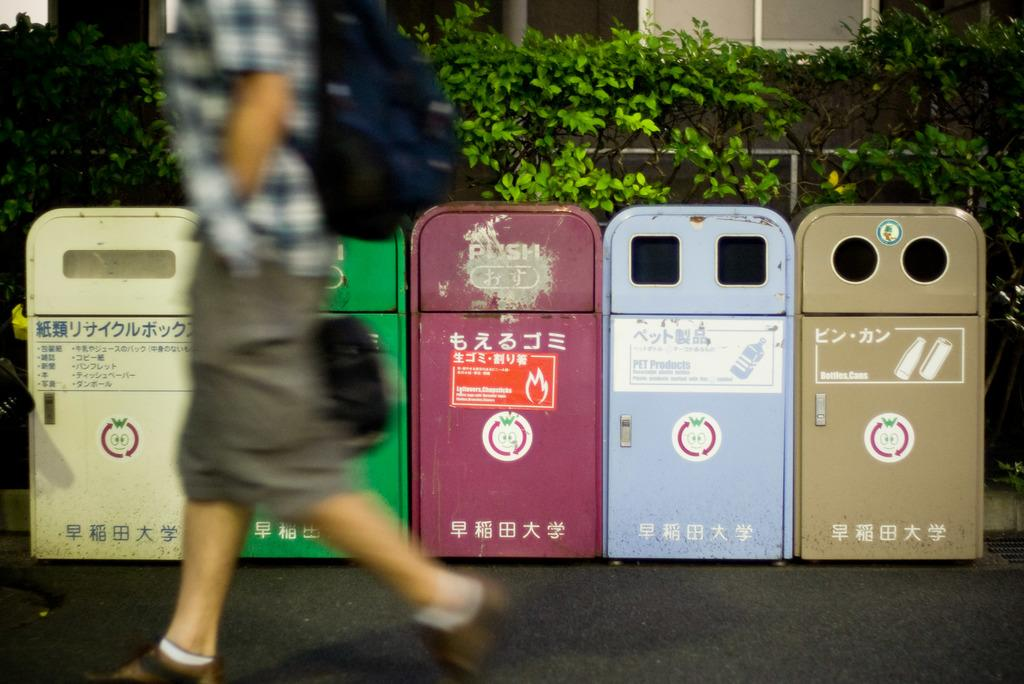<image>
Write a terse but informative summary of the picture. Many bins are lined up and one says "Bottles, Cans". 